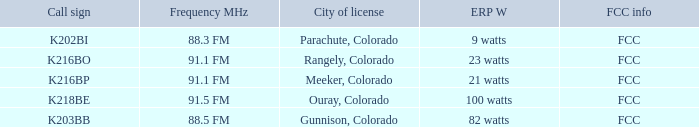Which ERP W has a Frequency MHz of 88.5 FM? 82 watts. 